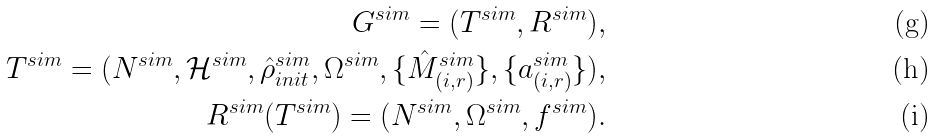Convert formula to latex. <formula><loc_0><loc_0><loc_500><loc_500>G ^ { s i m } = ( T ^ { s i m } , R ^ { s i m } ) , \\ T ^ { s i m } = ( N ^ { s i m } , \mathcal { H } ^ { s i m } , \hat { \rho } ^ { s i m } _ { i n i t } , \Omega ^ { s i m } , \{ \hat { M } _ { ( i , r ) } ^ { s i m } \} , \{ a _ { ( i , r ) } ^ { s i m } \} ) , \\ R ^ { s i m } ( T ^ { s i m } ) = ( N ^ { s i m } , \Omega ^ { s i m } , f ^ { s i m } ) .</formula> 